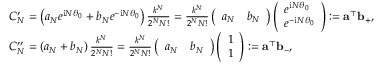<formula> <loc_0><loc_0><loc_500><loc_500>\begin{array} { r l } & { C _ { N } ^ { \prime } = \left ( { a _ { N } } { e ^ { i N \theta _ { 0 } } } + { b _ { N } } { e ^ { - i N \theta _ { 0 } } } \right ) { \frac { { { k ^ { N } } } } { { { 2 ^ { N } } N ! } } } = { \frac { { { k ^ { N } } } } { { { 2 ^ { N } } N ! } } } \left ( \begin{array} { l l } { a _ { N } } & { b _ { N } } \end{array} \right ) \left ( \begin{array} { l } { e ^ { i N \theta _ { 0 } } } \\ { e ^ { - i N \theta _ { 0 } } } \end{array} \right ) \colon = \mathbf a ^ { \top } \mathbf b _ { + } , } \\ & { C _ { N } ^ { \prime \prime } = \left ( { a _ { N } } + { b _ { N } } \right ) { \frac { { { k ^ { N } } } } { { { 2 ^ { N } } N ! } } } = { \frac { { { k ^ { N } } } } { { { 2 ^ { N } } N ! } } } \left ( \begin{array} { l l } { a _ { N } } & { b _ { N } } \end{array} \right ) \left ( \begin{array} { l } { 1 } \\ { 1 } \end{array} \right ) \colon = \mathbf a ^ { \top } \mathbf b _ { - } , } \end{array}</formula> 